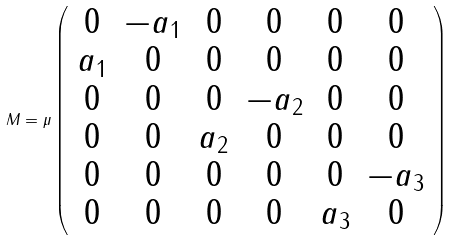<formula> <loc_0><loc_0><loc_500><loc_500>M = \mu \left ( \begin{array} { c c c c c c } 0 & - a _ { 1 } & 0 & 0 & 0 & 0 \\ a _ { 1 } & 0 & 0 & 0 & 0 & 0 \\ 0 & 0 & 0 & - a _ { 2 } & 0 & 0 \\ 0 & 0 & a _ { 2 } & 0 & 0 & 0 \\ 0 & 0 & 0 & 0 & 0 & - a _ { 3 } \\ 0 & 0 & 0 & 0 & a _ { 3 } & 0 \end{array} \right )</formula> 